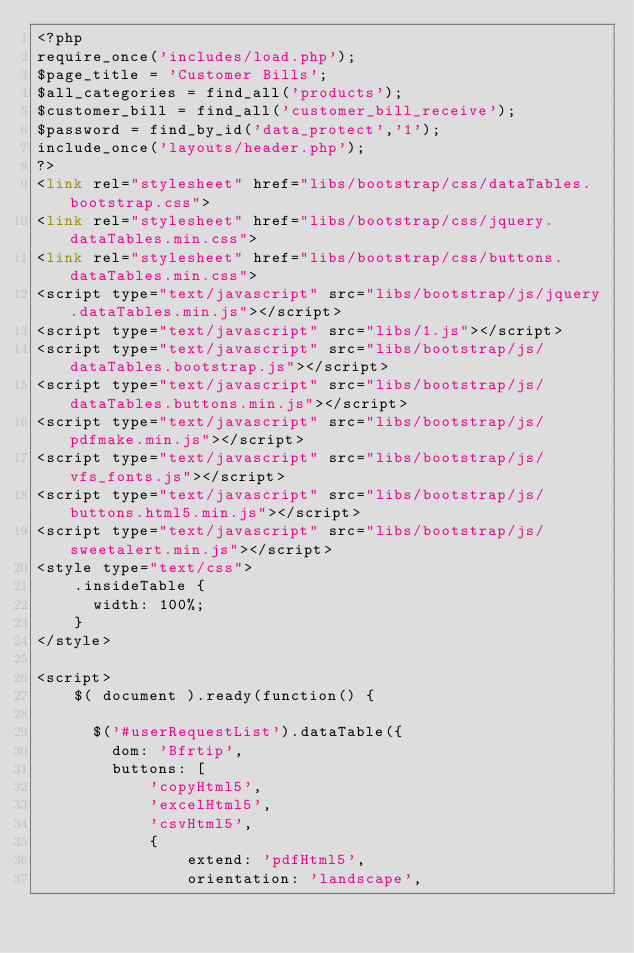<code> <loc_0><loc_0><loc_500><loc_500><_PHP_><?php
require_once('includes/load.php');
$page_title = 'Customer Bills';
$all_categories = find_all('products');
$customer_bill = find_all('customer_bill_receive');
$password = find_by_id('data_protect','1');
include_once('layouts/header.php');
?>  
<link rel="stylesheet" href="libs/bootstrap/css/dataTables.bootstrap.css">
<link rel="stylesheet" href="libs/bootstrap/css/jquery.dataTables.min.css">
<link rel="stylesheet" href="libs/bootstrap/css/buttons.dataTables.min.css">
<script type="text/javascript" src="libs/bootstrap/js/jquery.dataTables.min.js"></script>
<script type="text/javascript" src="libs/1.js"></script>
<script type="text/javascript" src="libs/bootstrap/js/dataTables.bootstrap.js"></script>
<script type="text/javascript" src="libs/bootstrap/js/dataTables.buttons.min.js"></script>
<script type="text/javascript" src="libs/bootstrap/js/pdfmake.min.js"></script>
<script type="text/javascript" src="libs/bootstrap/js/vfs_fonts.js"></script>
<script type="text/javascript" src="libs/bootstrap/js/buttons.html5.min.js"></script>
<script type="text/javascript" src="libs/bootstrap/js/sweetalert.min.js"></script>
<style type="text/css">
    .insideTable {
      width: 100%;
    }
</style>
      
<script>
    $( document ).ready(function() {
      
      $('#userRequestList').dataTable({
        dom: 'Bfrtip',
        buttons: [
            'copyHtml5',
            'excelHtml5',
            'csvHtml5',
            {
                extend: 'pdfHtml5',
                orientation: 'landscape',</code> 